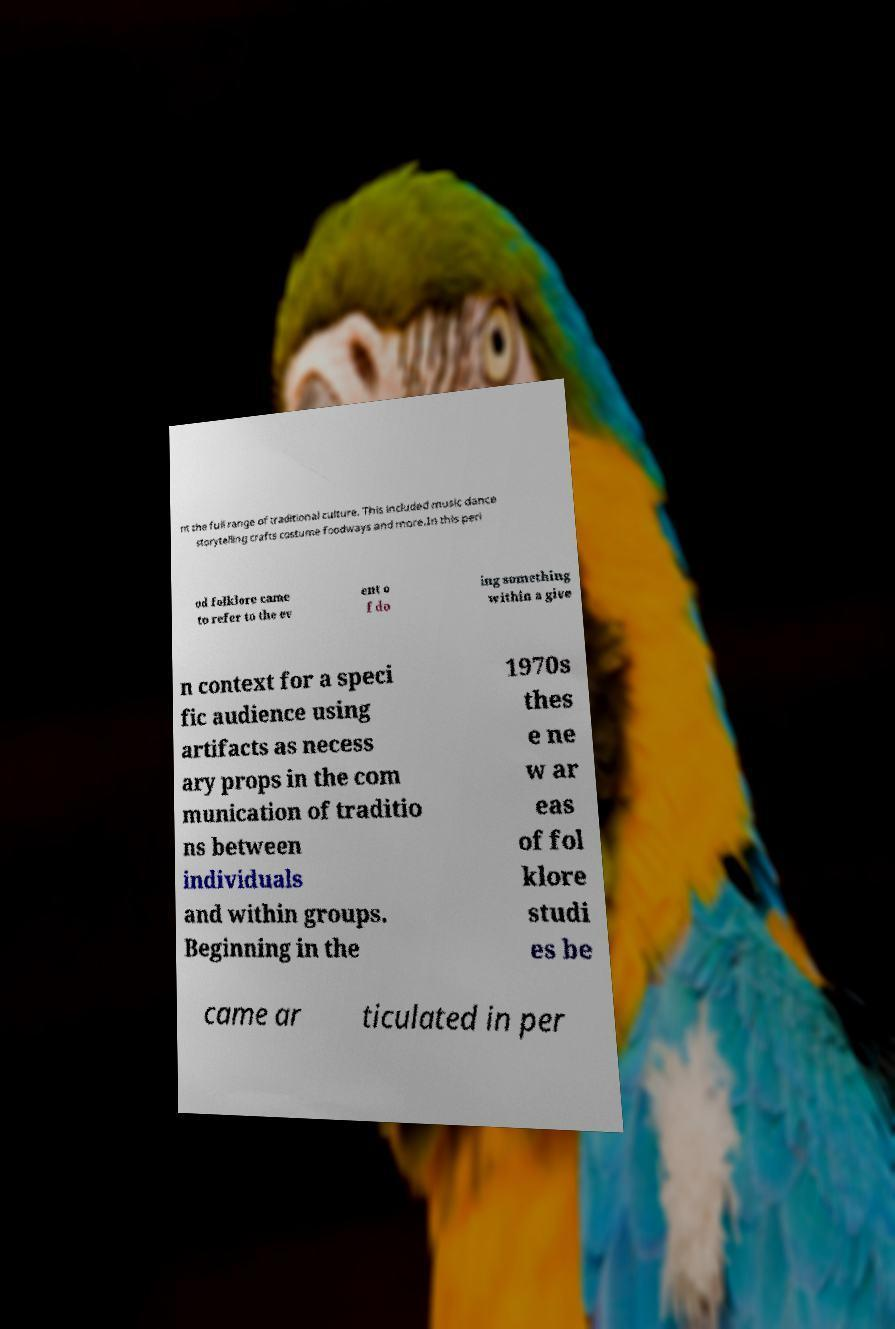Can you accurately transcribe the text from the provided image for me? nt the full range of traditional culture. This included music dance storytelling crafts costume foodways and more.In this peri od folklore came to refer to the ev ent o f do ing something within a give n context for a speci fic audience using artifacts as necess ary props in the com munication of traditio ns between individuals and within groups. Beginning in the 1970s thes e ne w ar eas of fol klore studi es be came ar ticulated in per 